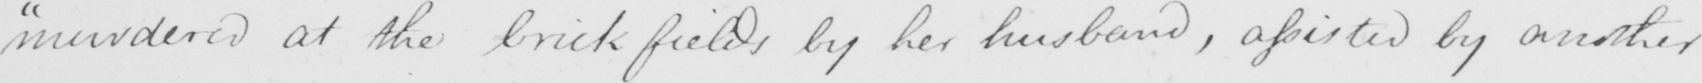Can you read and transcribe this handwriting? "murdered at the brickfields by her husband, assisted by another 